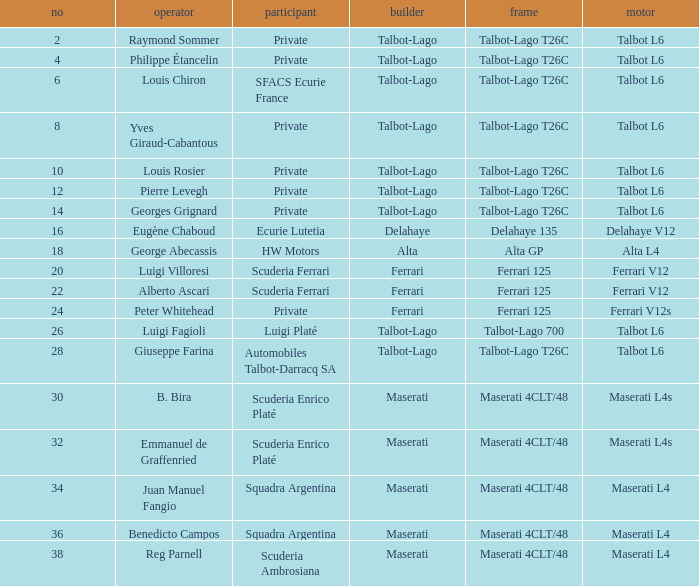Could you parse the entire table? {'header': ['no', 'operator', 'participant', 'builder', 'frame', 'motor'], 'rows': [['2', 'Raymond Sommer', 'Private', 'Talbot-Lago', 'Talbot-Lago T26C', 'Talbot L6'], ['4', 'Philippe Étancelin', 'Private', 'Talbot-Lago', 'Talbot-Lago T26C', 'Talbot L6'], ['6', 'Louis Chiron', 'SFACS Ecurie France', 'Talbot-Lago', 'Talbot-Lago T26C', 'Talbot L6'], ['8', 'Yves Giraud-Cabantous', 'Private', 'Talbot-Lago', 'Talbot-Lago T26C', 'Talbot L6'], ['10', 'Louis Rosier', 'Private', 'Talbot-Lago', 'Talbot-Lago T26C', 'Talbot L6'], ['12', 'Pierre Levegh', 'Private', 'Talbot-Lago', 'Talbot-Lago T26C', 'Talbot L6'], ['14', 'Georges Grignard', 'Private', 'Talbot-Lago', 'Talbot-Lago T26C', 'Talbot L6'], ['16', 'Eugène Chaboud', 'Ecurie Lutetia', 'Delahaye', 'Delahaye 135', 'Delahaye V12'], ['18', 'George Abecassis', 'HW Motors', 'Alta', 'Alta GP', 'Alta L4'], ['20', 'Luigi Villoresi', 'Scuderia Ferrari', 'Ferrari', 'Ferrari 125', 'Ferrari V12'], ['22', 'Alberto Ascari', 'Scuderia Ferrari', 'Ferrari', 'Ferrari 125', 'Ferrari V12'], ['24', 'Peter Whitehead', 'Private', 'Ferrari', 'Ferrari 125', 'Ferrari V12s'], ['26', 'Luigi Fagioli', 'Luigi Platé', 'Talbot-Lago', 'Talbot-Lago 700', 'Talbot L6'], ['28', 'Giuseppe Farina', 'Automobiles Talbot-Darracq SA', 'Talbot-Lago', 'Talbot-Lago T26C', 'Talbot L6'], ['30', 'B. Bira', 'Scuderia Enrico Platé', 'Maserati', 'Maserati 4CLT/48', 'Maserati L4s'], ['32', 'Emmanuel de Graffenried', 'Scuderia Enrico Platé', 'Maserati', 'Maserati 4CLT/48', 'Maserati L4s'], ['34', 'Juan Manuel Fangio', 'Squadra Argentina', 'Maserati', 'Maserati 4CLT/48', 'Maserati L4'], ['36', 'Benedicto Campos', 'Squadra Argentina', 'Maserati', 'Maserati 4CLT/48', 'Maserati L4'], ['38', 'Reg Parnell', 'Scuderia Ambrosiana', 'Maserati', 'Maserati 4CLT/48', 'Maserati L4']]} Name the constructor for b. bira Maserati. 